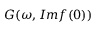<formula> <loc_0><loc_0><loc_500><loc_500>G ( \omega , I m f ( 0 ) )</formula> 